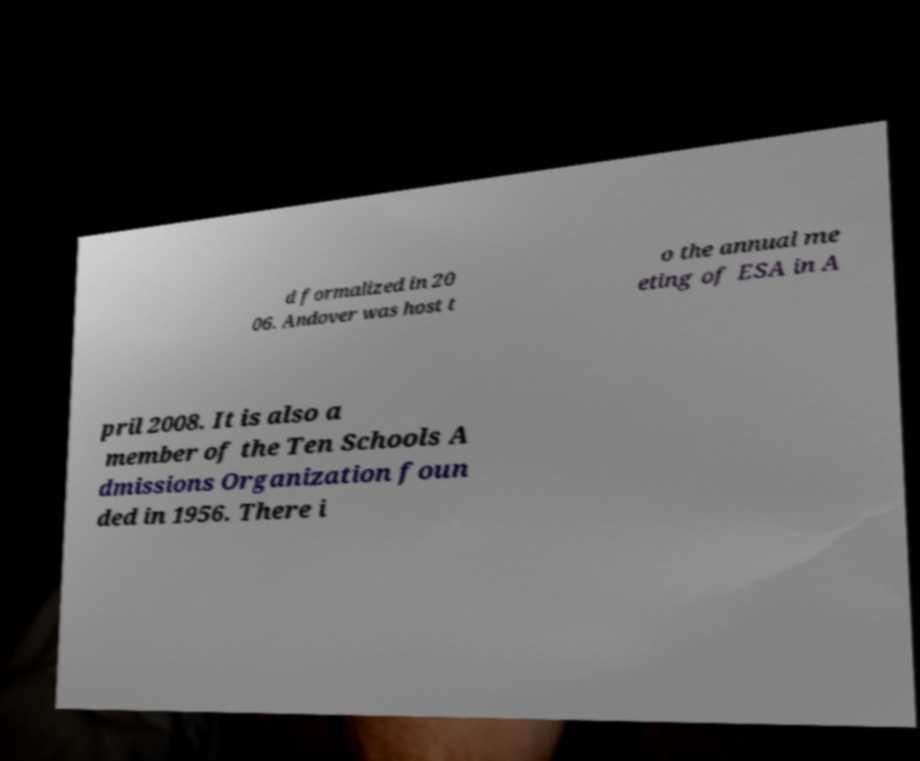Please read and relay the text visible in this image. What does it say? d formalized in 20 06. Andover was host t o the annual me eting of ESA in A pril 2008. It is also a member of the Ten Schools A dmissions Organization foun ded in 1956. There i 